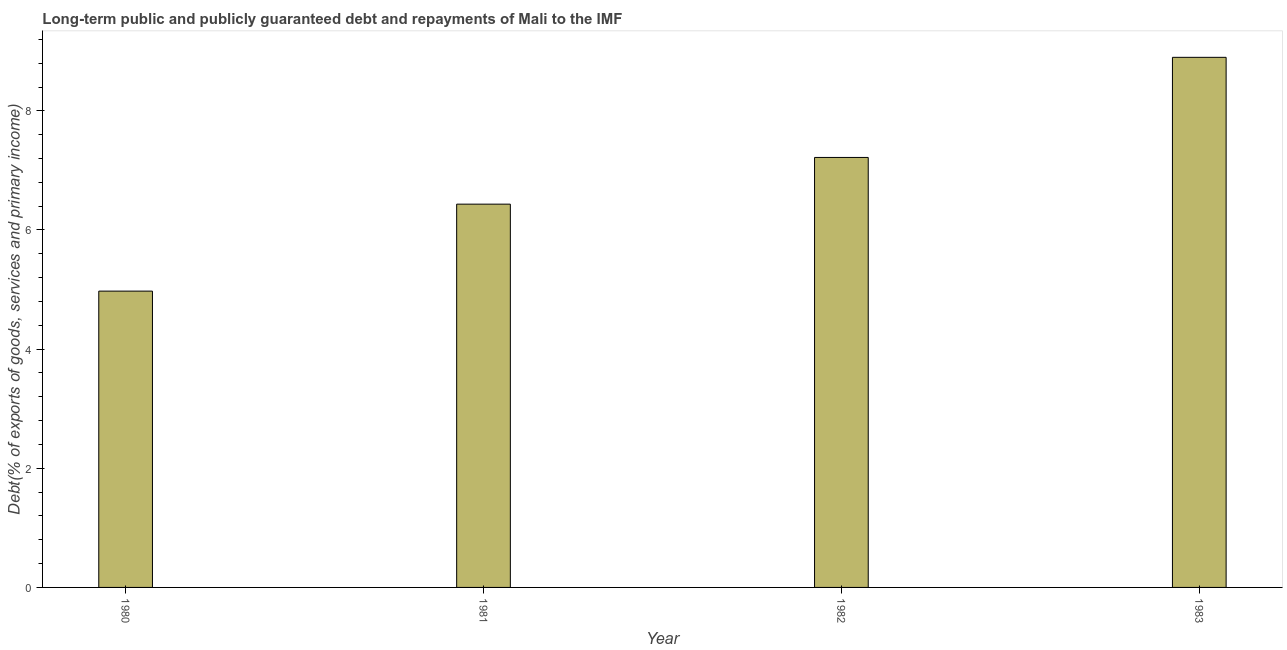Does the graph contain any zero values?
Make the answer very short. No. Does the graph contain grids?
Offer a terse response. No. What is the title of the graph?
Your answer should be very brief. Long-term public and publicly guaranteed debt and repayments of Mali to the IMF. What is the label or title of the X-axis?
Make the answer very short. Year. What is the label or title of the Y-axis?
Keep it short and to the point. Debt(% of exports of goods, services and primary income). What is the debt service in 1983?
Make the answer very short. 8.9. Across all years, what is the maximum debt service?
Your answer should be very brief. 8.9. Across all years, what is the minimum debt service?
Provide a succinct answer. 4.97. What is the sum of the debt service?
Your response must be concise. 27.52. What is the difference between the debt service in 1980 and 1981?
Your answer should be very brief. -1.46. What is the average debt service per year?
Your answer should be compact. 6.88. What is the median debt service?
Your response must be concise. 6.83. Do a majority of the years between 1983 and 1981 (inclusive) have debt service greater than 6.8 %?
Provide a succinct answer. Yes. What is the ratio of the debt service in 1982 to that in 1983?
Your response must be concise. 0.81. What is the difference between the highest and the second highest debt service?
Offer a very short reply. 1.68. Is the sum of the debt service in 1981 and 1983 greater than the maximum debt service across all years?
Your answer should be very brief. Yes. What is the difference between the highest and the lowest debt service?
Provide a short and direct response. 3.92. In how many years, is the debt service greater than the average debt service taken over all years?
Offer a terse response. 2. How many bars are there?
Ensure brevity in your answer.  4. Are all the bars in the graph horizontal?
Your response must be concise. No. What is the difference between two consecutive major ticks on the Y-axis?
Provide a succinct answer. 2. What is the Debt(% of exports of goods, services and primary income) in 1980?
Provide a short and direct response. 4.97. What is the Debt(% of exports of goods, services and primary income) in 1981?
Give a very brief answer. 6.43. What is the Debt(% of exports of goods, services and primary income) of 1982?
Provide a short and direct response. 7.22. What is the Debt(% of exports of goods, services and primary income) of 1983?
Provide a succinct answer. 8.9. What is the difference between the Debt(% of exports of goods, services and primary income) in 1980 and 1981?
Offer a terse response. -1.46. What is the difference between the Debt(% of exports of goods, services and primary income) in 1980 and 1982?
Ensure brevity in your answer.  -2.24. What is the difference between the Debt(% of exports of goods, services and primary income) in 1980 and 1983?
Your response must be concise. -3.92. What is the difference between the Debt(% of exports of goods, services and primary income) in 1981 and 1982?
Give a very brief answer. -0.78. What is the difference between the Debt(% of exports of goods, services and primary income) in 1981 and 1983?
Your answer should be compact. -2.46. What is the difference between the Debt(% of exports of goods, services and primary income) in 1982 and 1983?
Your response must be concise. -1.68. What is the ratio of the Debt(% of exports of goods, services and primary income) in 1980 to that in 1981?
Keep it short and to the point. 0.77. What is the ratio of the Debt(% of exports of goods, services and primary income) in 1980 to that in 1982?
Offer a terse response. 0.69. What is the ratio of the Debt(% of exports of goods, services and primary income) in 1980 to that in 1983?
Provide a succinct answer. 0.56. What is the ratio of the Debt(% of exports of goods, services and primary income) in 1981 to that in 1982?
Make the answer very short. 0.89. What is the ratio of the Debt(% of exports of goods, services and primary income) in 1981 to that in 1983?
Your answer should be compact. 0.72. What is the ratio of the Debt(% of exports of goods, services and primary income) in 1982 to that in 1983?
Provide a succinct answer. 0.81. 